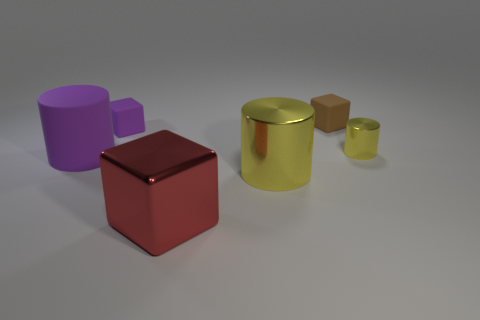Add 2 purple metal spheres. How many objects exist? 8 Subtract all matte cylinders. How many cylinders are left? 2 Subtract 2 cylinders. How many cylinders are left? 1 Subtract all purple cylinders. How many cylinders are left? 2 Subtract 1 purple blocks. How many objects are left? 5 Subtract all yellow cylinders. Subtract all green spheres. How many cylinders are left? 1 Subtract all purple balls. How many yellow cylinders are left? 2 Subtract all purple matte cubes. Subtract all yellow shiny cylinders. How many objects are left? 3 Add 1 purple things. How many purple things are left? 3 Add 5 large things. How many large things exist? 8 